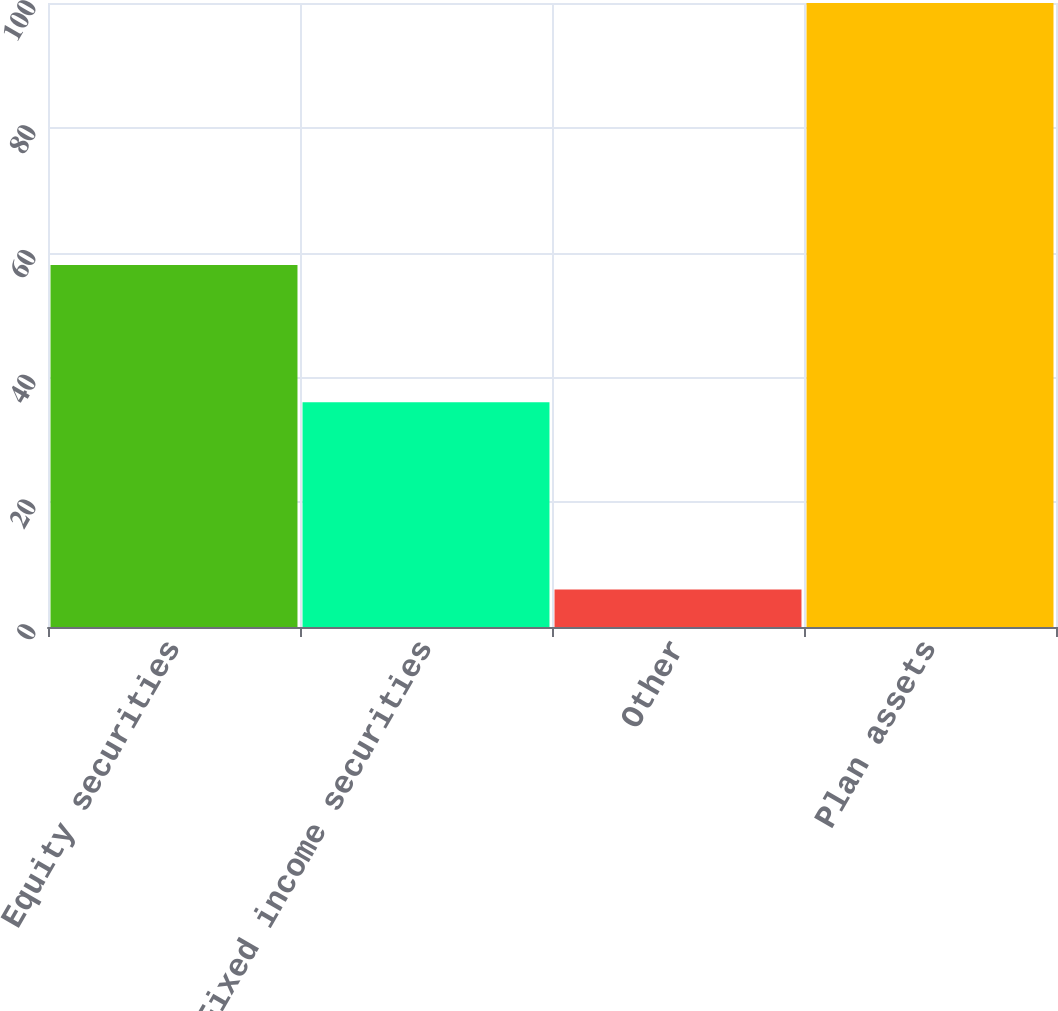Convert chart to OTSL. <chart><loc_0><loc_0><loc_500><loc_500><bar_chart><fcel>Equity securities<fcel>Fixed income securities<fcel>Other<fcel>Plan assets<nl><fcel>58<fcel>36<fcel>6<fcel>100<nl></chart> 